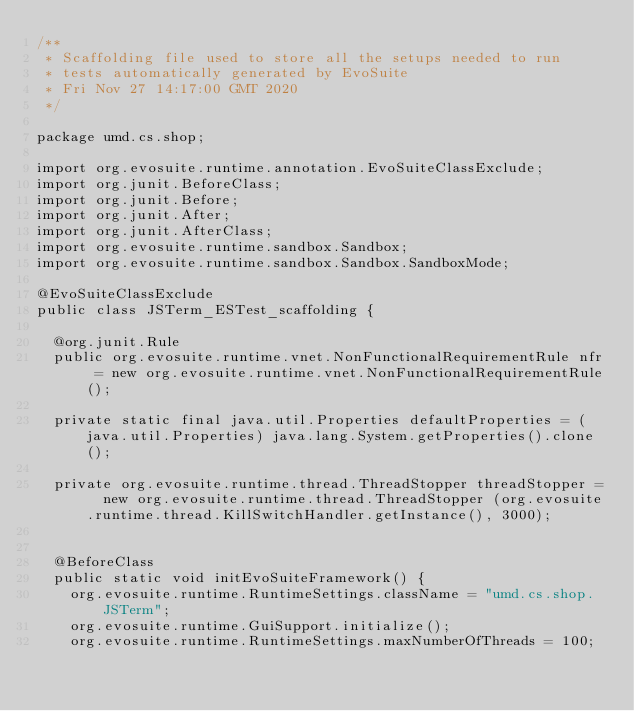<code> <loc_0><loc_0><loc_500><loc_500><_Java_>/**
 * Scaffolding file used to store all the setups needed to run 
 * tests automatically generated by EvoSuite
 * Fri Nov 27 14:17:00 GMT 2020
 */

package umd.cs.shop;

import org.evosuite.runtime.annotation.EvoSuiteClassExclude;
import org.junit.BeforeClass;
import org.junit.Before;
import org.junit.After;
import org.junit.AfterClass;
import org.evosuite.runtime.sandbox.Sandbox;
import org.evosuite.runtime.sandbox.Sandbox.SandboxMode;

@EvoSuiteClassExclude
public class JSTerm_ESTest_scaffolding {

  @org.junit.Rule 
  public org.evosuite.runtime.vnet.NonFunctionalRequirementRule nfr = new org.evosuite.runtime.vnet.NonFunctionalRequirementRule();

  private static final java.util.Properties defaultProperties = (java.util.Properties) java.lang.System.getProperties().clone(); 

  private org.evosuite.runtime.thread.ThreadStopper threadStopper =  new org.evosuite.runtime.thread.ThreadStopper (org.evosuite.runtime.thread.KillSwitchHandler.getInstance(), 3000);


  @BeforeClass 
  public static void initEvoSuiteFramework() { 
    org.evosuite.runtime.RuntimeSettings.className = "umd.cs.shop.JSTerm"; 
    org.evosuite.runtime.GuiSupport.initialize(); 
    org.evosuite.runtime.RuntimeSettings.maxNumberOfThreads = 100; </code> 